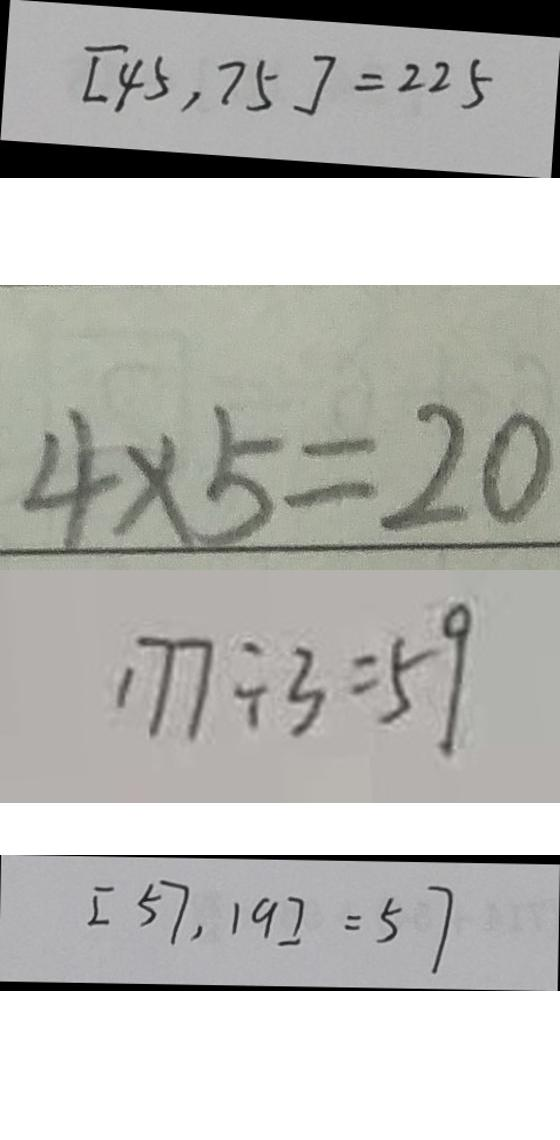<formula> <loc_0><loc_0><loc_500><loc_500>[ 4 5 , 7 5 ] = 2 2 5 
 4 \times 5 = 2 0 
 1 7 7 \div 3 = 5 9 
 [ 5 7 , 1 9 ] = 5 7</formula> 